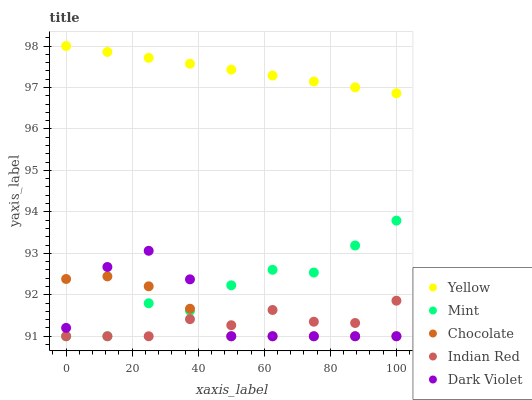Does Indian Red have the minimum area under the curve?
Answer yes or no. Yes. Does Yellow have the maximum area under the curve?
Answer yes or no. Yes. Does Mint have the minimum area under the curve?
Answer yes or no. No. Does Mint have the maximum area under the curve?
Answer yes or no. No. Is Yellow the smoothest?
Answer yes or no. Yes. Is Dark Violet the roughest?
Answer yes or no. Yes. Is Mint the smoothest?
Answer yes or no. No. Is Mint the roughest?
Answer yes or no. No. Does Dark Violet have the lowest value?
Answer yes or no. Yes. Does Yellow have the lowest value?
Answer yes or no. No. Does Yellow have the highest value?
Answer yes or no. Yes. Does Mint have the highest value?
Answer yes or no. No. Is Mint less than Yellow?
Answer yes or no. Yes. Is Yellow greater than Mint?
Answer yes or no. Yes. Does Indian Red intersect Dark Violet?
Answer yes or no. Yes. Is Indian Red less than Dark Violet?
Answer yes or no. No. Is Indian Red greater than Dark Violet?
Answer yes or no. No. Does Mint intersect Yellow?
Answer yes or no. No. 